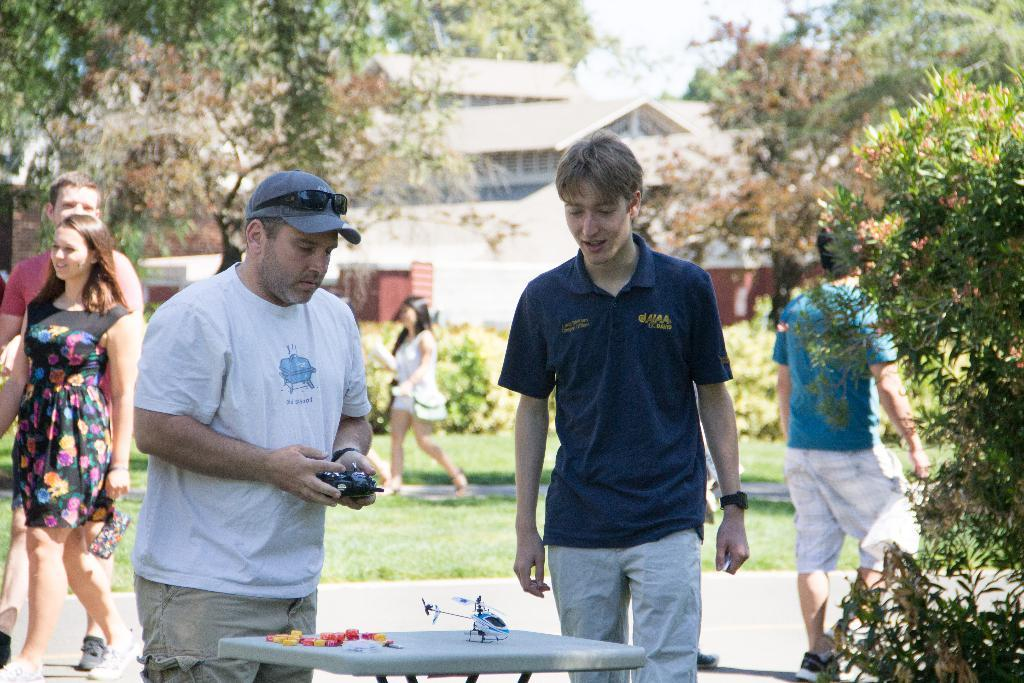What type of vegetation can be seen in the image? There is grass, plants, and trees in the image. Are there any living beings present in the image? Yes, there are people in the image. What type of structure can be seen in the image? There is a table and houses in the image. What part of the natural environment is visible in the image? The sky is visible in the image. Where is the club located in the image? There is no club present in the image. What type of oven can be seen in the image? There is no oven present in the image. 